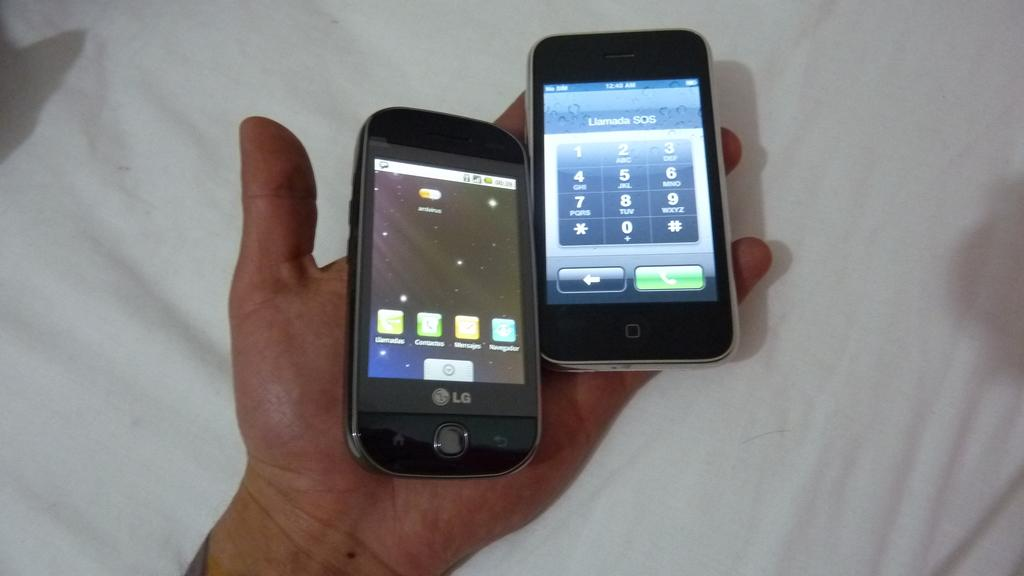<image>
Describe the image concisely. A hand has two cell phones and the one on the lft is an LG phone. 